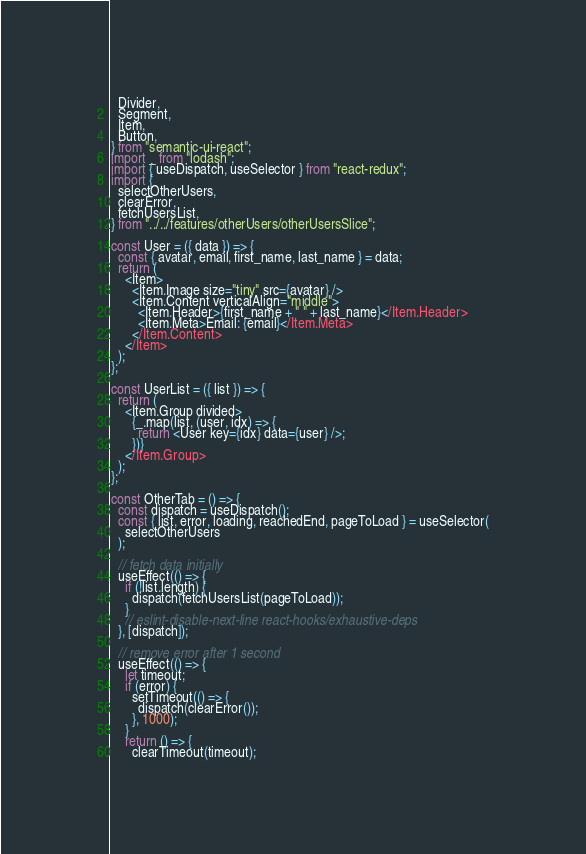<code> <loc_0><loc_0><loc_500><loc_500><_JavaScript_>  Divider,
  Segment,
  Item,
  Button,
} from "semantic-ui-react";
import _ from "lodash";
import { useDispatch, useSelector } from "react-redux";
import {
  selectOtherUsers,
  clearError,
  fetchUsersList,
} from "../../features/otherUsers/otherUsersSlice";

const User = ({ data }) => {
  const { avatar, email, first_name, last_name } = data;
  return (
    <Item>
      <Item.Image size="tiny" src={avatar} />
      <Item.Content verticalAlign="middle">
        <Item.Header>{first_name + " " + last_name}</Item.Header>
        <Item.Meta>Email: {email}</Item.Meta>
      </Item.Content>
    </Item>
  );
};

const UserList = ({ list }) => {
  return (
    <Item.Group divided>
      {_.map(list, (user, idx) => {
        return <User key={idx} data={user} />;
      })}
    </Item.Group>
  );
};

const OtherTab = () => {
  const dispatch = useDispatch();
  const { list, error, loading, reachedEnd, pageToLoad } = useSelector(
    selectOtherUsers
  );

  // fetch data initially
  useEffect(() => {
    if (!list.length) {
      dispatch(fetchUsersList(pageToLoad));
    }
    // eslint-disable-next-line react-hooks/exhaustive-deps
  }, [dispatch]);

  // remove error after 1 second
  useEffect(() => {
    let timeout;
    if (error) {
      setTimeout(() => {
        dispatch(clearError());
      }, 1000);
    }
    return () => {
      clearTimeout(timeout);</code> 